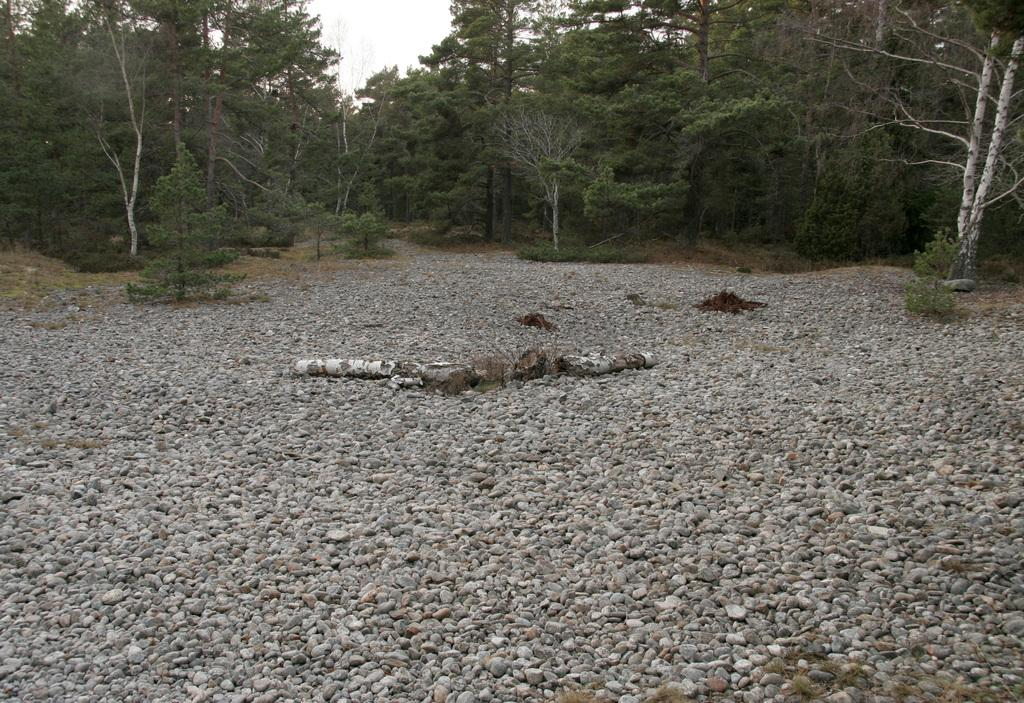What type of vegetation is present in the image? There are many trees in the image. What object can be seen on the ground? There is a wooden log on the ground. What type of natural elements are present in the image? There are many stones in the image. What is visible in the background of the image? The sky is visible in the image. What type of honey can be seen dripping from the pipe in the image? There is no honey or pipe present in the image. What type of dinner is being served in the image? There is no dinner or any food being served in the image. 